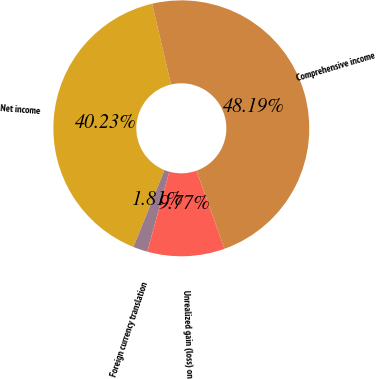Convert chart. <chart><loc_0><loc_0><loc_500><loc_500><pie_chart><fcel>Net income<fcel>Foreign currency translation<fcel>Unrealized gain (loss) on<fcel>Comprehensive income<nl><fcel>40.23%<fcel>1.81%<fcel>9.77%<fcel>48.19%<nl></chart> 